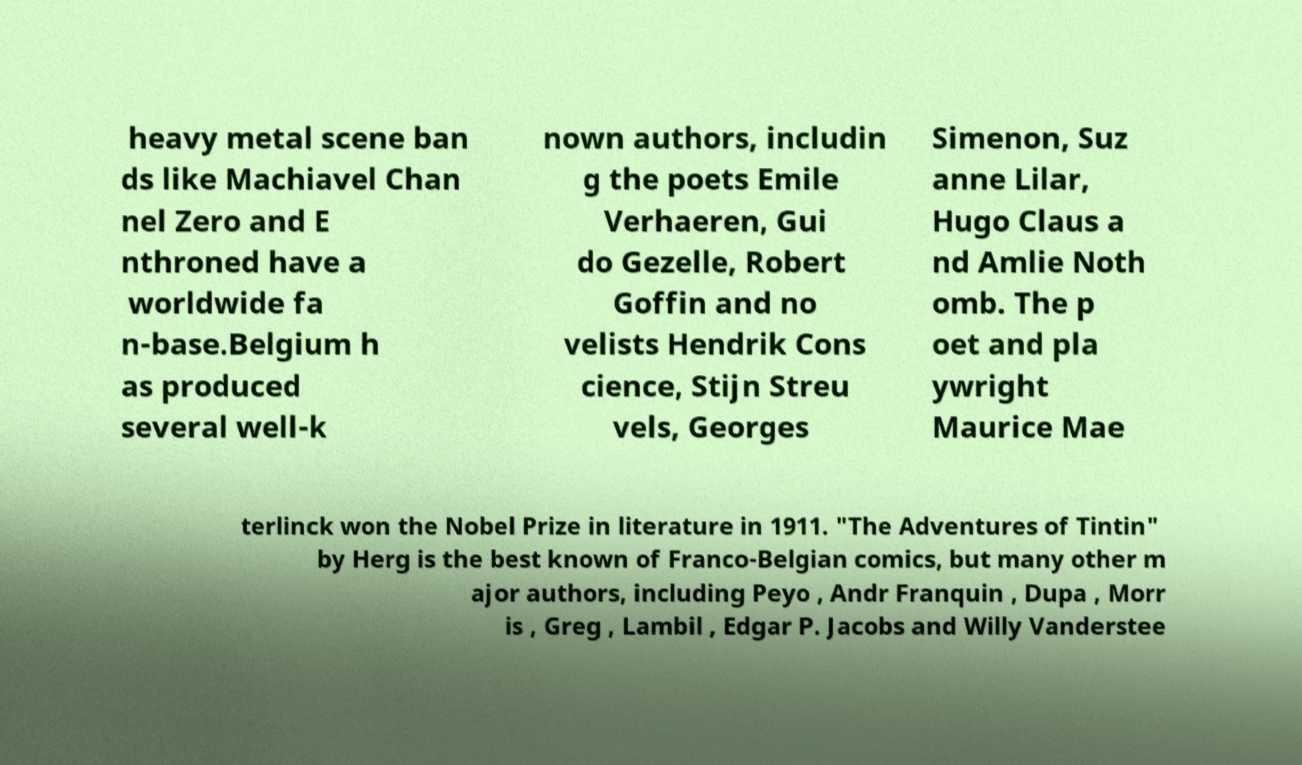Could you assist in decoding the text presented in this image and type it out clearly? heavy metal scene ban ds like Machiavel Chan nel Zero and E nthroned have a worldwide fa n-base.Belgium h as produced several well-k nown authors, includin g the poets Emile Verhaeren, Gui do Gezelle, Robert Goffin and no velists Hendrik Cons cience, Stijn Streu vels, Georges Simenon, Suz anne Lilar, Hugo Claus a nd Amlie Noth omb. The p oet and pla ywright Maurice Mae terlinck won the Nobel Prize in literature in 1911. "The Adventures of Tintin" by Herg is the best known of Franco-Belgian comics, but many other m ajor authors, including Peyo , Andr Franquin , Dupa , Morr is , Greg , Lambil , Edgar P. Jacobs and Willy Vanderstee 